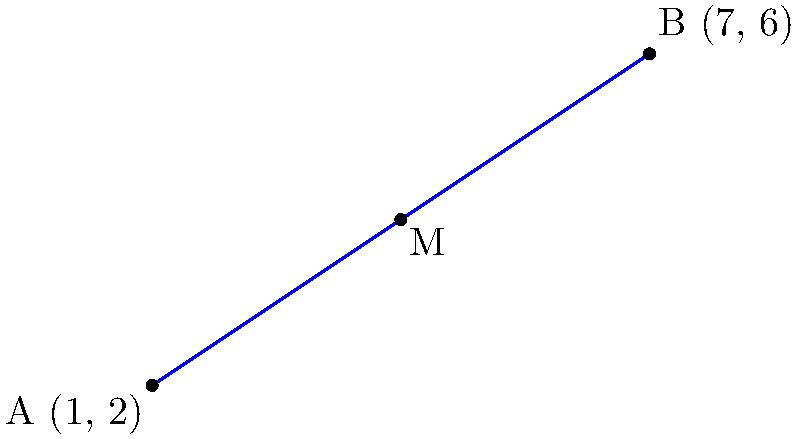In your virtual reality audio platform, you need to position a listener at the midpoint between two audio sources. Audio Source 1 is located at coordinates (1, 2) and Audio Source 2 is at (7, 6) in a 2D plane. Calculate the coordinates of the midpoint where the listener should be placed for optimal audio experience. To find the midpoint of a line segment connecting two points in a 2D plane, we use the midpoint formula:

$$ M_x = \frac{x_1 + x_2}{2}, \quad M_y = \frac{y_1 + y_2}{2} $$

Where $(x_1, y_1)$ are the coordinates of the first point and $(x_2, y_2)$ are the coordinates of the second point.

Step 1: Identify the coordinates
- Audio Source 1: $(x_1, y_1) = (1, 2)$
- Audio Source 2: $(x_2, y_2) = (7, 6)$

Step 2: Calculate the x-coordinate of the midpoint
$$ M_x = \frac{x_1 + x_2}{2} = \frac{1 + 7}{2} = \frac{8}{2} = 4 $$

Step 3: Calculate the y-coordinate of the midpoint
$$ M_y = \frac{y_1 + y_2}{2} = \frac{2 + 6}{2} = \frac{8}{2} = 4 $$

Step 4: Combine the results
The midpoint coordinates are $(M_x, M_y) = (4, 4)$
Answer: (4, 4) 